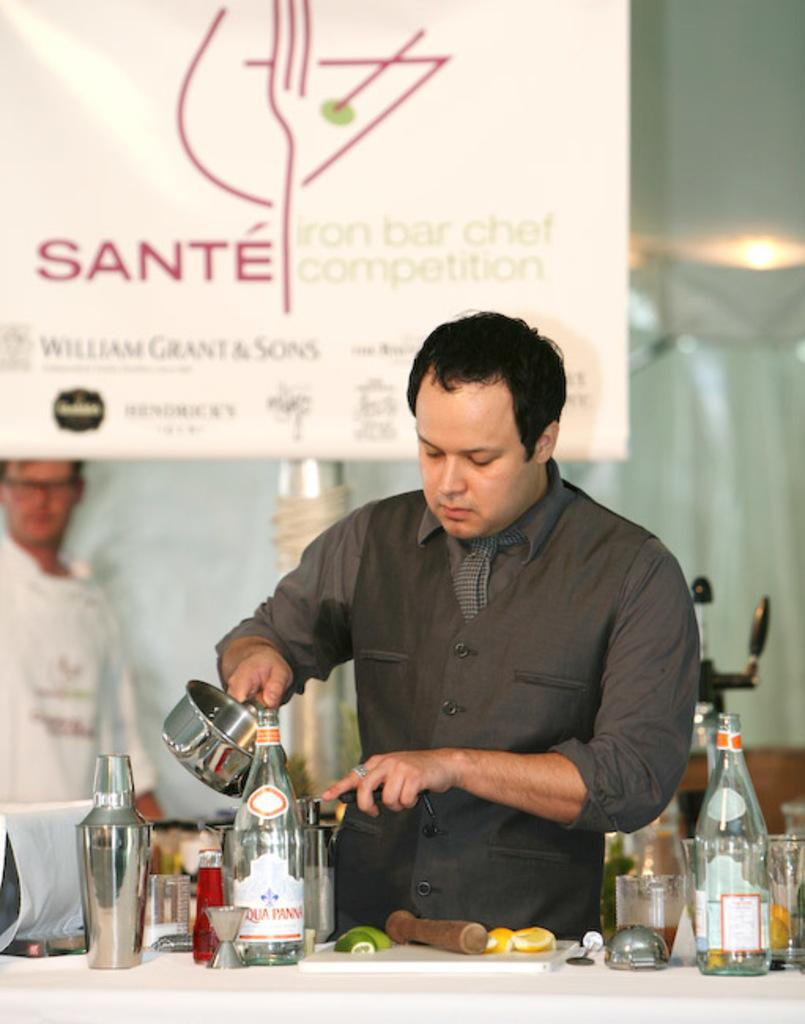<image>
Share a concise interpretation of the image provided. A man pours something from a pot at an Iron Chef competition. 